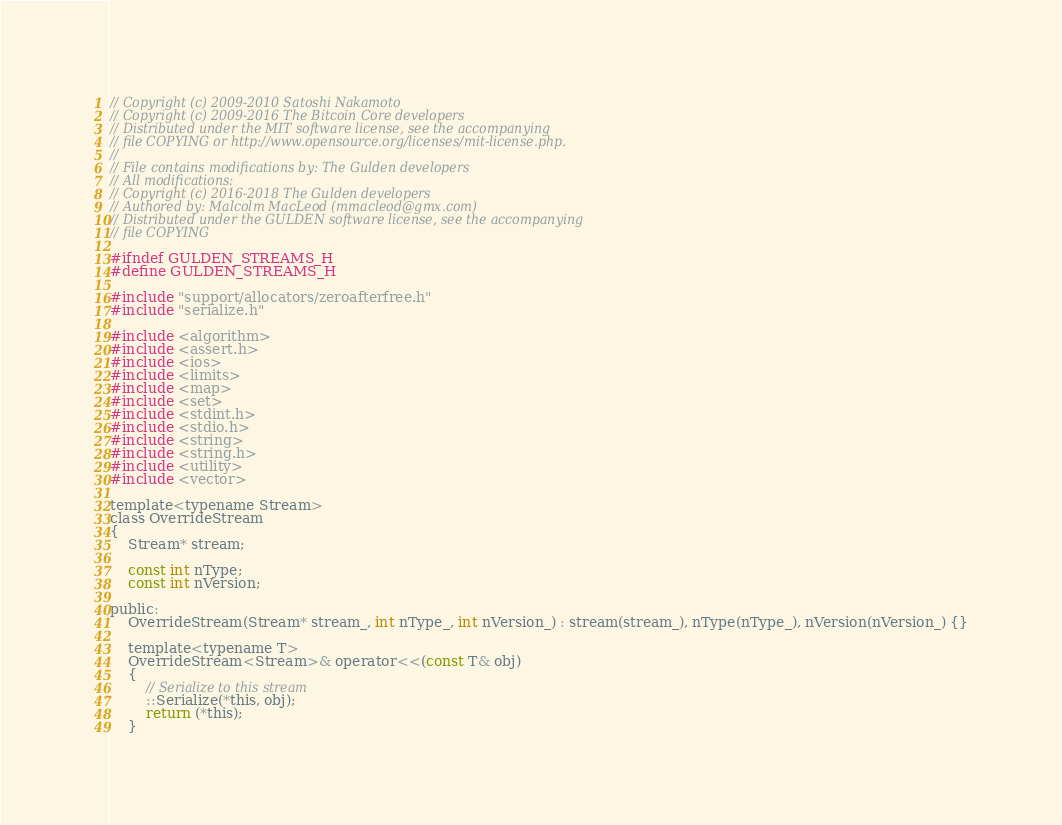<code> <loc_0><loc_0><loc_500><loc_500><_C_>// Copyright (c) 2009-2010 Satoshi Nakamoto
// Copyright (c) 2009-2016 The Bitcoin Core developers
// Distributed under the MIT software license, see the accompanying
// file COPYING or http://www.opensource.org/licenses/mit-license.php.
//
// File contains modifications by: The Gulden developers
// All modifications:
// Copyright (c) 2016-2018 The Gulden developers
// Authored by: Malcolm MacLeod (mmacleod@gmx.com)
// Distributed under the GULDEN software license, see the accompanying
// file COPYING

#ifndef GULDEN_STREAMS_H
#define GULDEN_STREAMS_H

#include "support/allocators/zeroafterfree.h"
#include "serialize.h"

#include <algorithm>
#include <assert.h>
#include <ios>
#include <limits>
#include <map>
#include <set>
#include <stdint.h>
#include <stdio.h>
#include <string>
#include <string.h>
#include <utility>
#include <vector>

template<typename Stream>
class OverrideStream
{
    Stream* stream;

    const int nType;
    const int nVersion;

public:
    OverrideStream(Stream* stream_, int nType_, int nVersion_) : stream(stream_), nType(nType_), nVersion(nVersion_) {}

    template<typename T>
    OverrideStream<Stream>& operator<<(const T& obj)
    {
        // Serialize to this stream
        ::Serialize(*this, obj);
        return (*this);
    }
</code> 